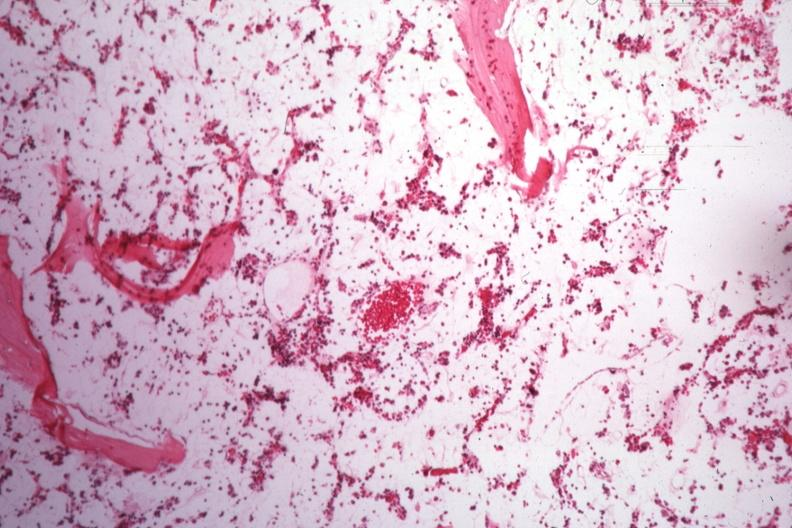s bone marrow present?
Answer the question using a single word or phrase. Yes 